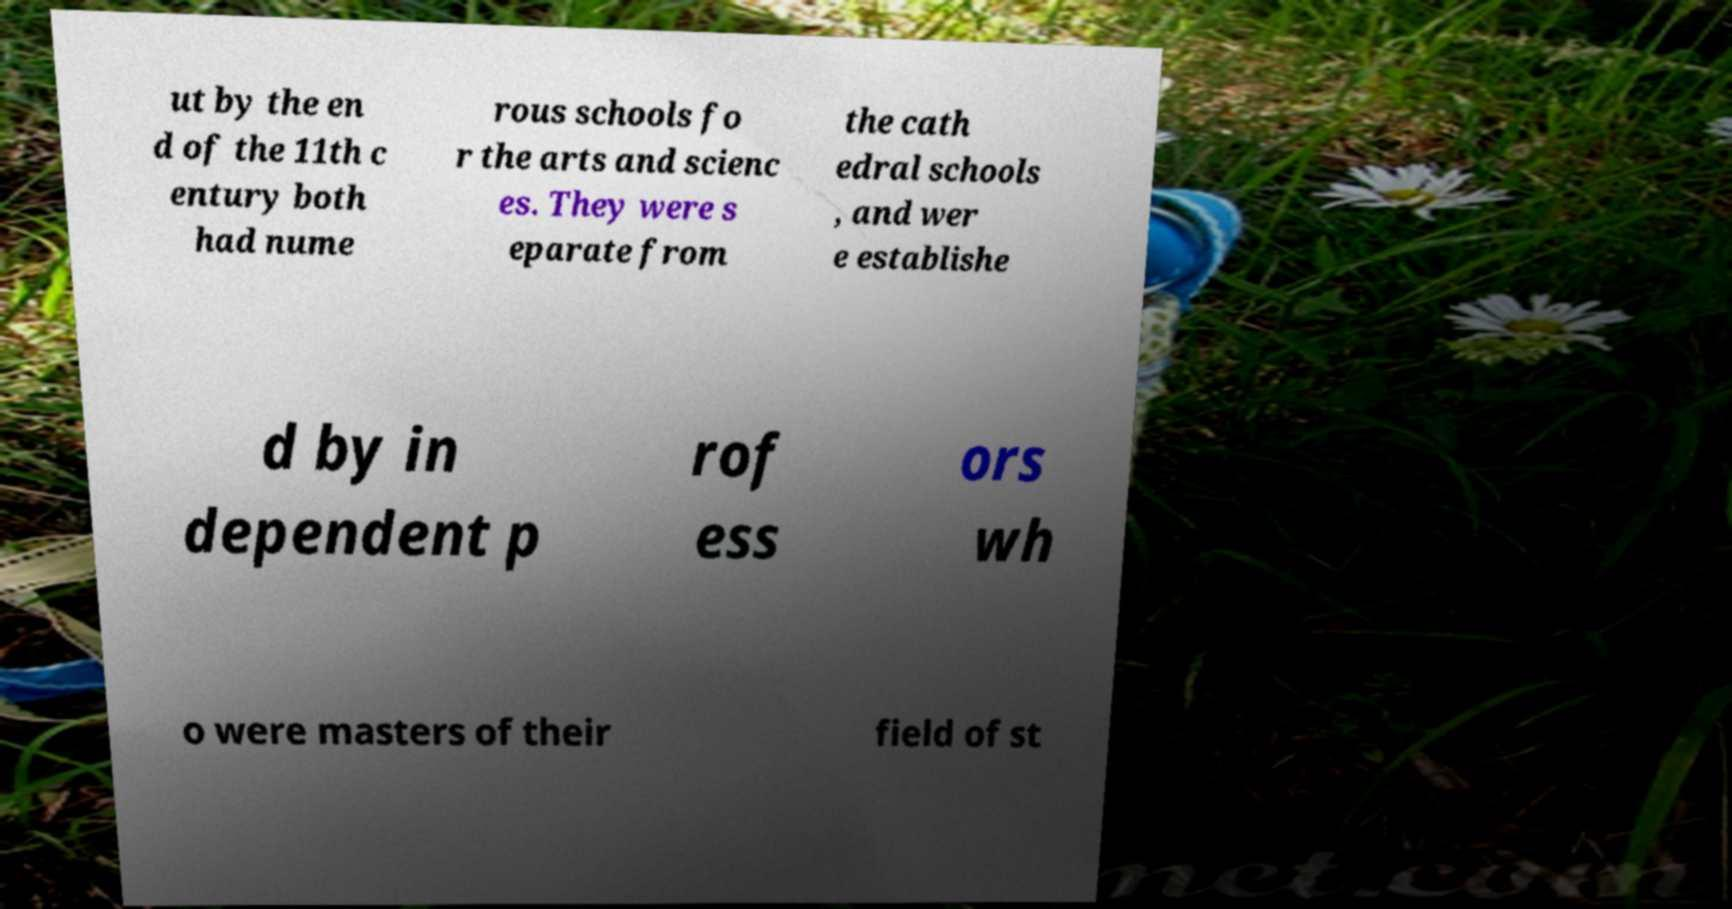For documentation purposes, I need the text within this image transcribed. Could you provide that? ut by the en d of the 11th c entury both had nume rous schools fo r the arts and scienc es. They were s eparate from the cath edral schools , and wer e establishe d by in dependent p rof ess ors wh o were masters of their field of st 